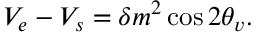Convert formula to latex. <formula><loc_0><loc_0><loc_500><loc_500>V _ { e } - V _ { s } = \delta m ^ { 2 } \cos { 2 \theta _ { v } } .</formula> 